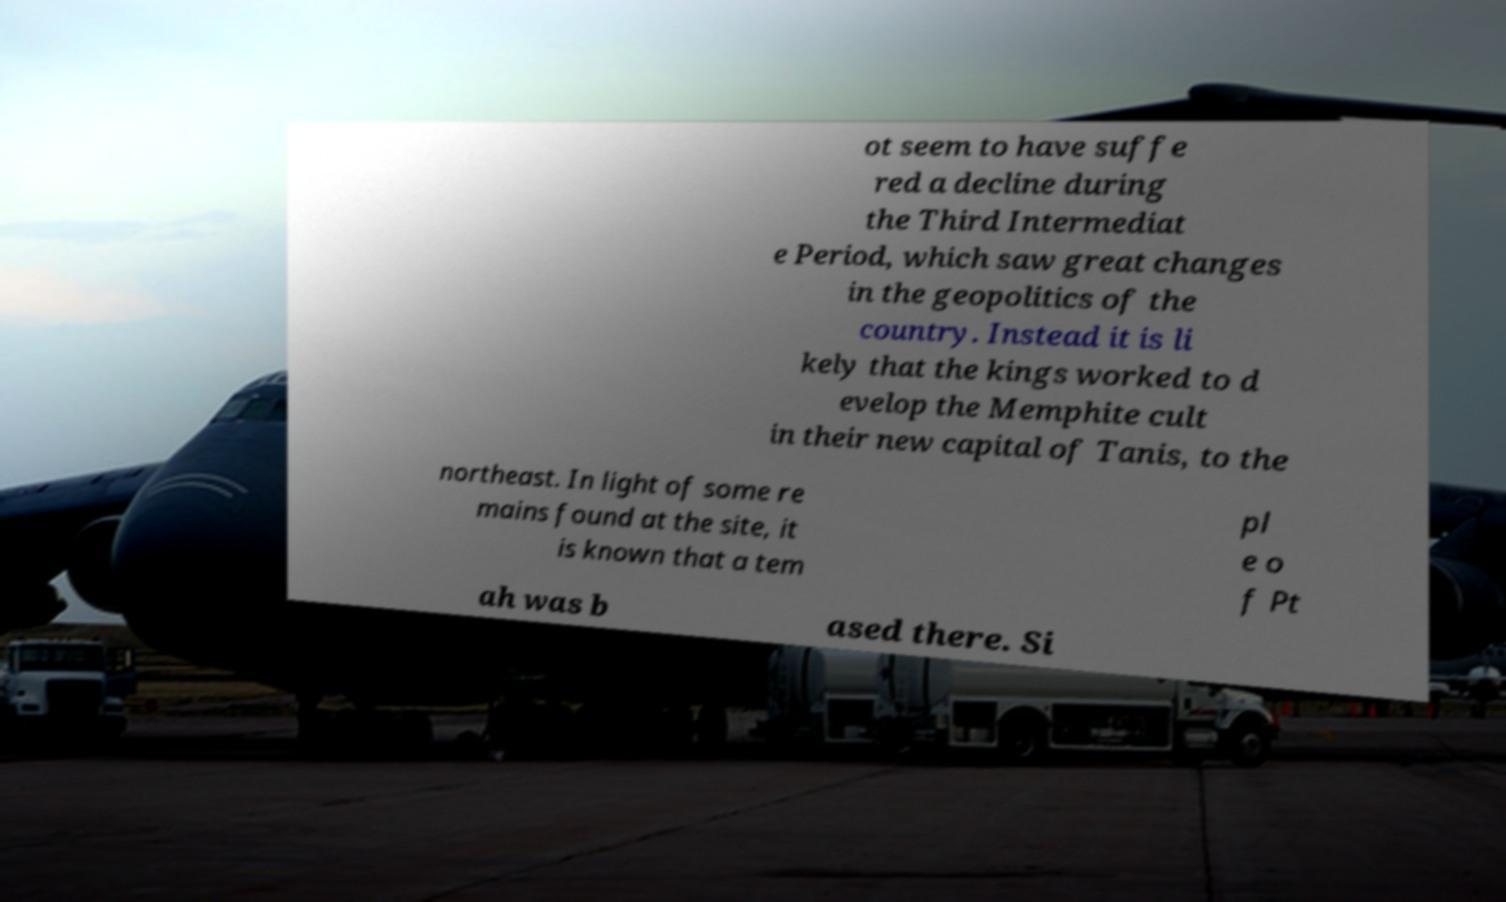Could you assist in decoding the text presented in this image and type it out clearly? ot seem to have suffe red a decline during the Third Intermediat e Period, which saw great changes in the geopolitics of the country. Instead it is li kely that the kings worked to d evelop the Memphite cult in their new capital of Tanis, to the northeast. In light of some re mains found at the site, it is known that a tem pl e o f Pt ah was b ased there. Si 